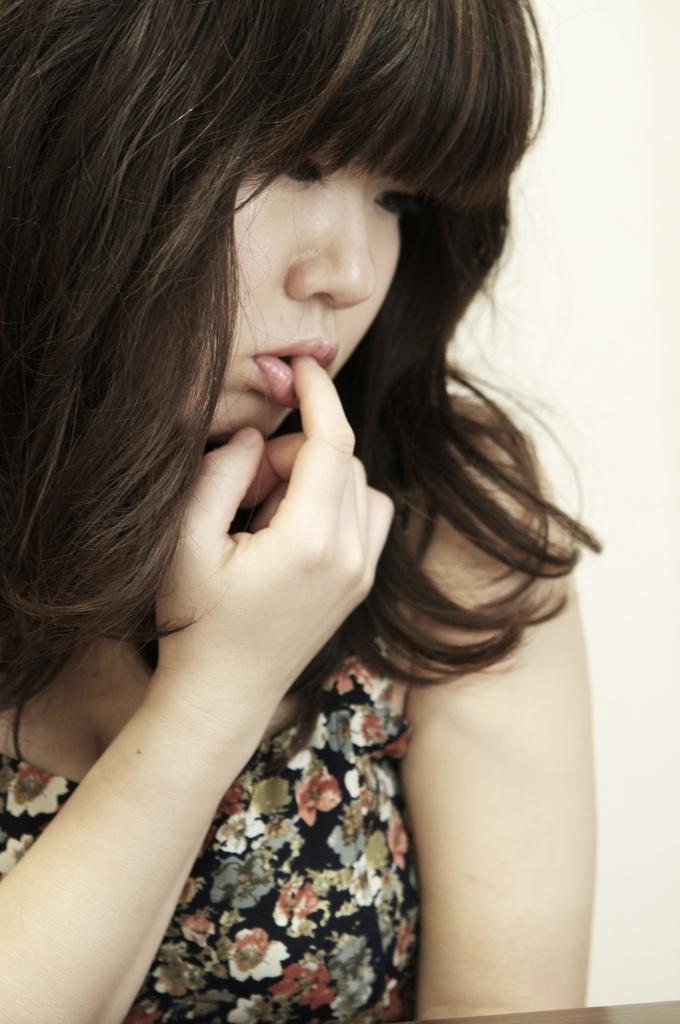Who is in the image? There is a woman in the image. What can be seen in the background of the image? The background of the image is white. What is the design on the woman's dress? The woman's dress has a design of flowers. What type of trail can be seen in the image? There is no trail present in the image. What is the woman using to create a tin sculpture in the image? There is no tin or sculpture present in the image. 